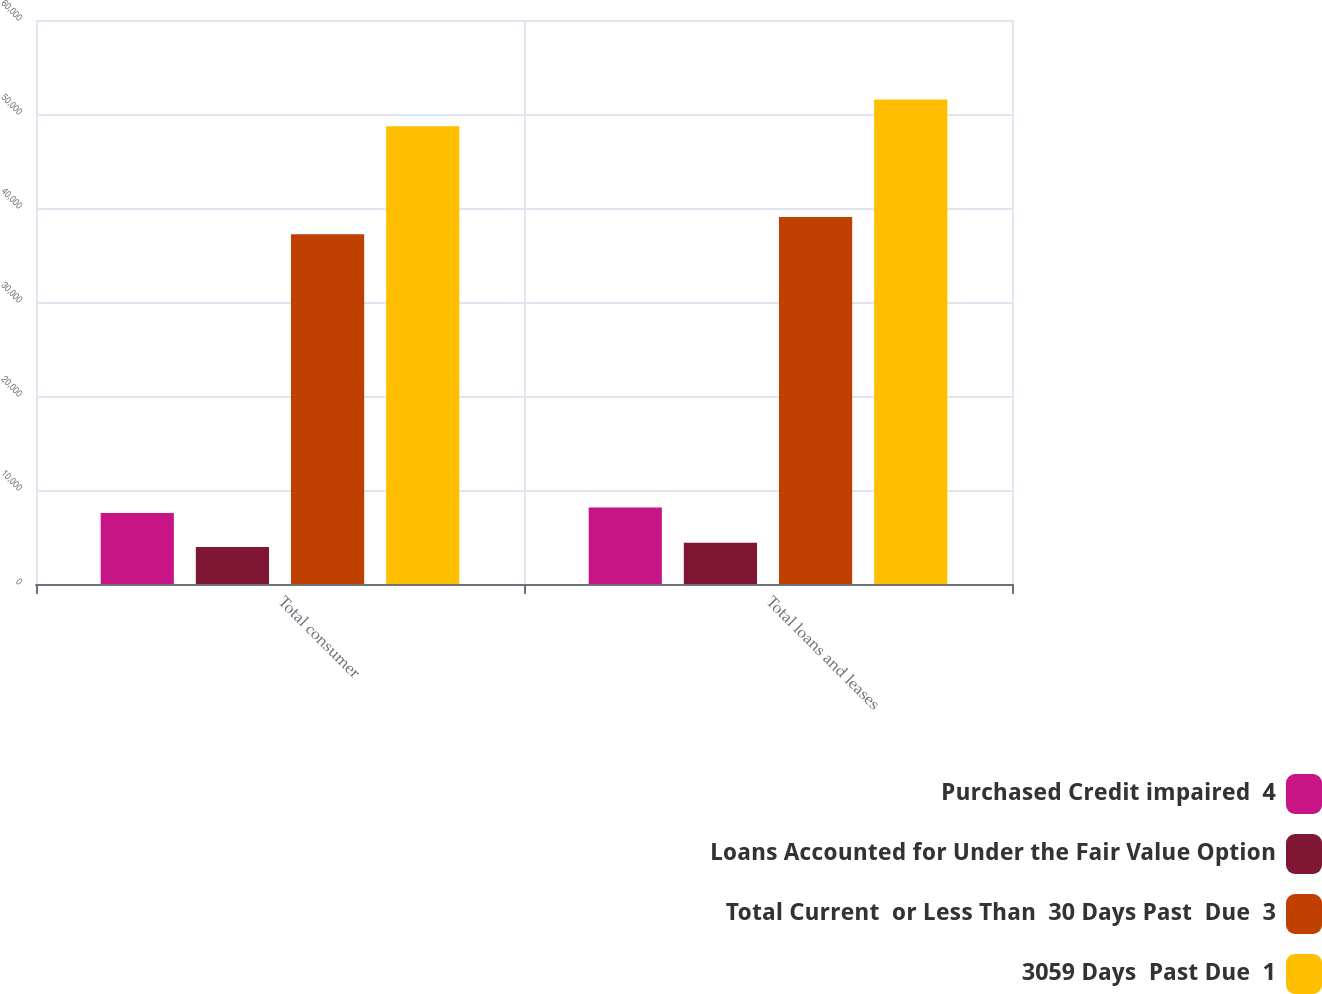<chart> <loc_0><loc_0><loc_500><loc_500><stacked_bar_chart><ecel><fcel>Total consumer<fcel>Total loans and leases<nl><fcel>Purchased Credit impaired  4<fcel>7545<fcel>8134<nl><fcel>Loans Accounted for Under the Fair Value Option<fcel>3948<fcel>4379<nl><fcel>Total Current  or Less Than  30 Days Past  Due  3<fcel>37216<fcel>39036<nl><fcel>3059 Days  Past Due  1<fcel>48709<fcel>51549<nl></chart> 